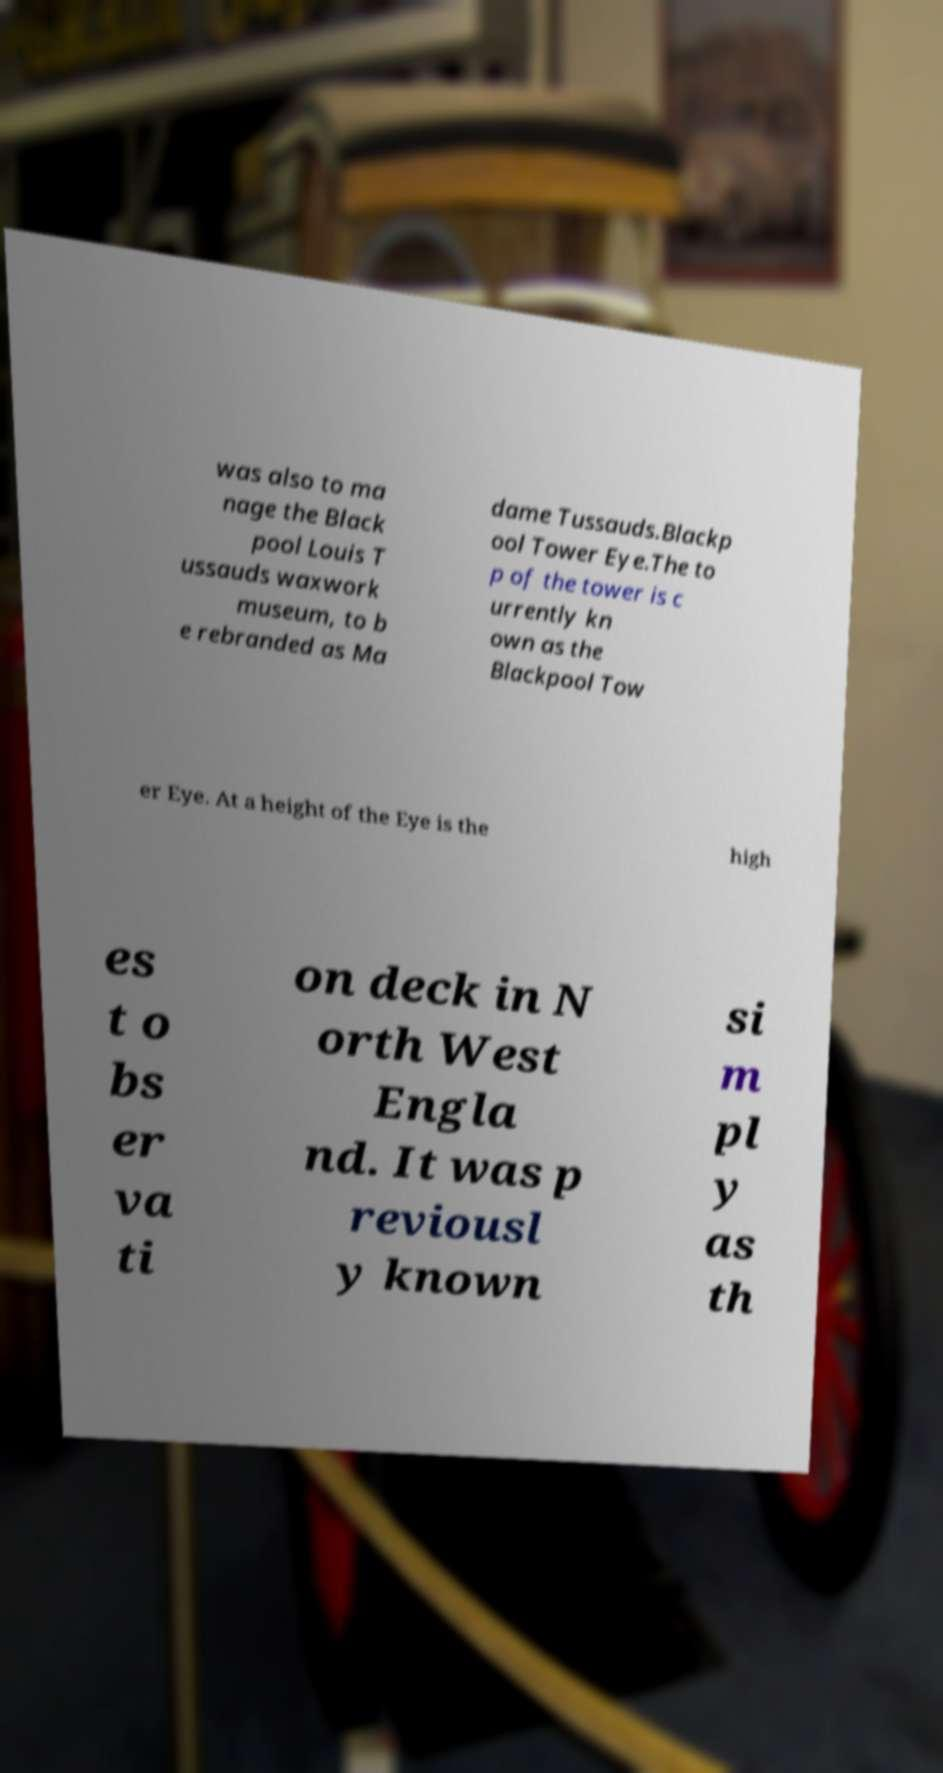There's text embedded in this image that I need extracted. Can you transcribe it verbatim? was also to ma nage the Black pool Louis T ussauds waxwork museum, to b e rebranded as Ma dame Tussauds.Blackp ool Tower Eye.The to p of the tower is c urrently kn own as the Blackpool Tow er Eye. At a height of the Eye is the high es t o bs er va ti on deck in N orth West Engla nd. It was p reviousl y known si m pl y as th 